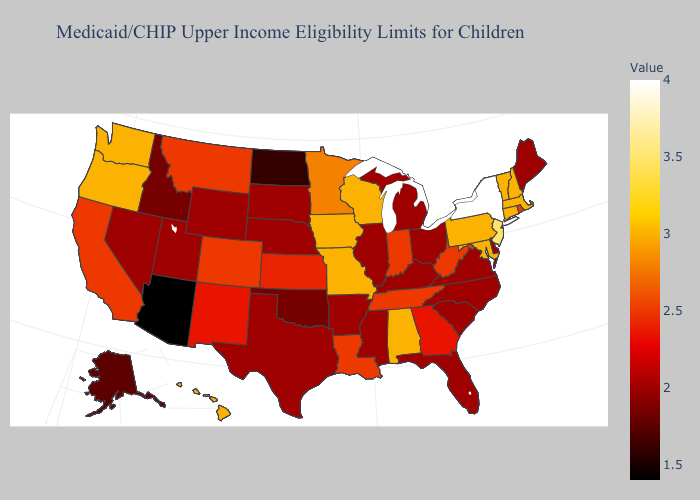Does Kansas have a lower value than Minnesota?
Short answer required. Yes. Among the states that border Colorado , which have the highest value?
Give a very brief answer. Kansas. Does the map have missing data?
Be succinct. No. Among the states that border Mississippi , which have the highest value?
Concise answer only. Alabama. Does Maryland have the highest value in the South?
Write a very short answer. Yes. 